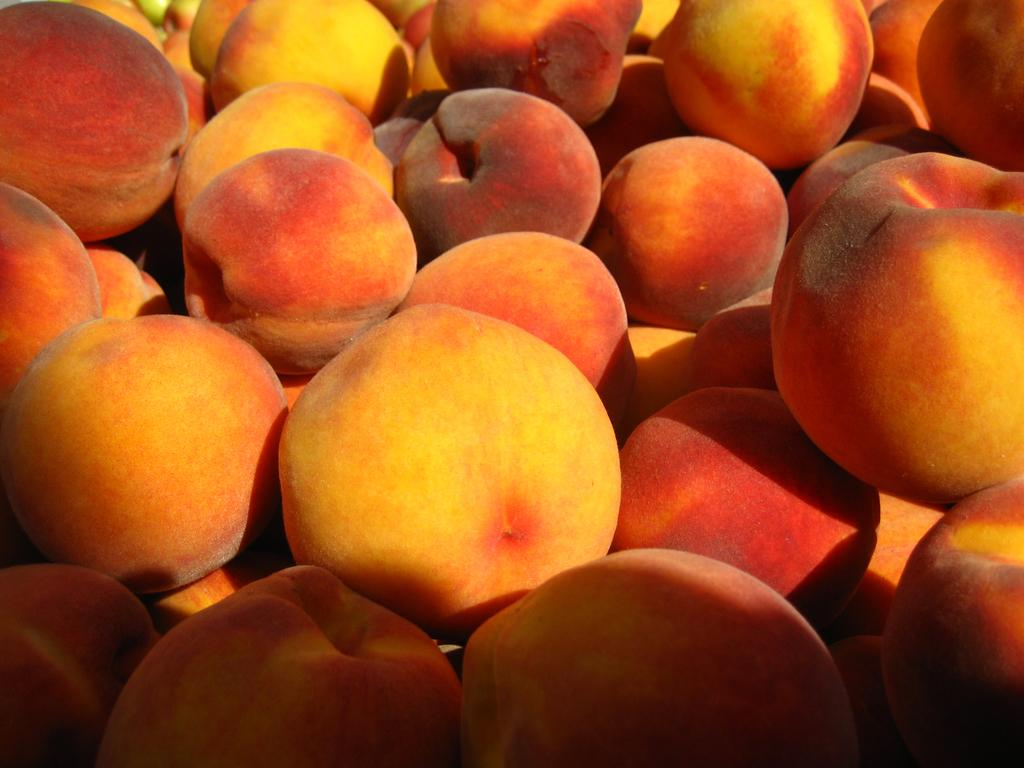What type of food can be seen in the image? There are fruits in the image. Can you describe the appearance of the fruits? The fruits look like apples. What type of map can be seen in the image? There is no map present in the image; it features fruits that look like apples. Are there any mountains visible in the image? There are no mountains present in the image; it features fruits that look like apples. 